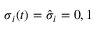Convert formula to latex. <formula><loc_0><loc_0><loc_500><loc_500>\sigma _ { i } ( t ) = \hat { \sigma } _ { i } = 0 , 1</formula> 